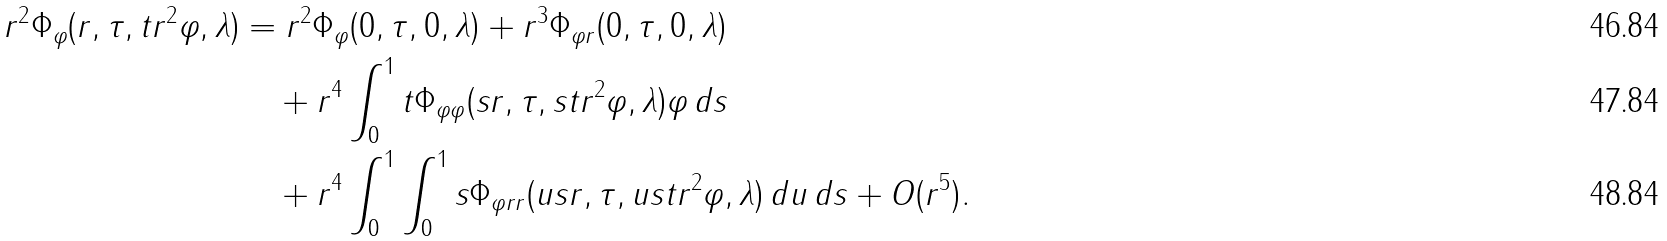Convert formula to latex. <formula><loc_0><loc_0><loc_500><loc_500>r ^ { 2 } \Phi _ { \varphi } ( r , \tau , t r ^ { 2 } \varphi , \lambda ) & = r ^ { 2 } \Phi _ { \varphi } ( 0 , \tau , 0 , \lambda ) + r ^ { 3 } \Phi _ { \varphi r } ( 0 , \tau , 0 , \lambda ) \\ & \quad + r ^ { 4 } \int _ { 0 } ^ { 1 } t \Phi _ { \varphi \varphi } ( s r , \tau , s t r ^ { 2 } \varphi , \lambda ) \varphi \, d s \\ & \quad + r ^ { 4 } \int _ { 0 } ^ { 1 } \int _ { 0 } ^ { 1 } s \Phi _ { \varphi r r } ( u s r , \tau , u s t r ^ { 2 } \varphi , \lambda ) \, d u \, d s + O ( r ^ { 5 } ) .</formula> 